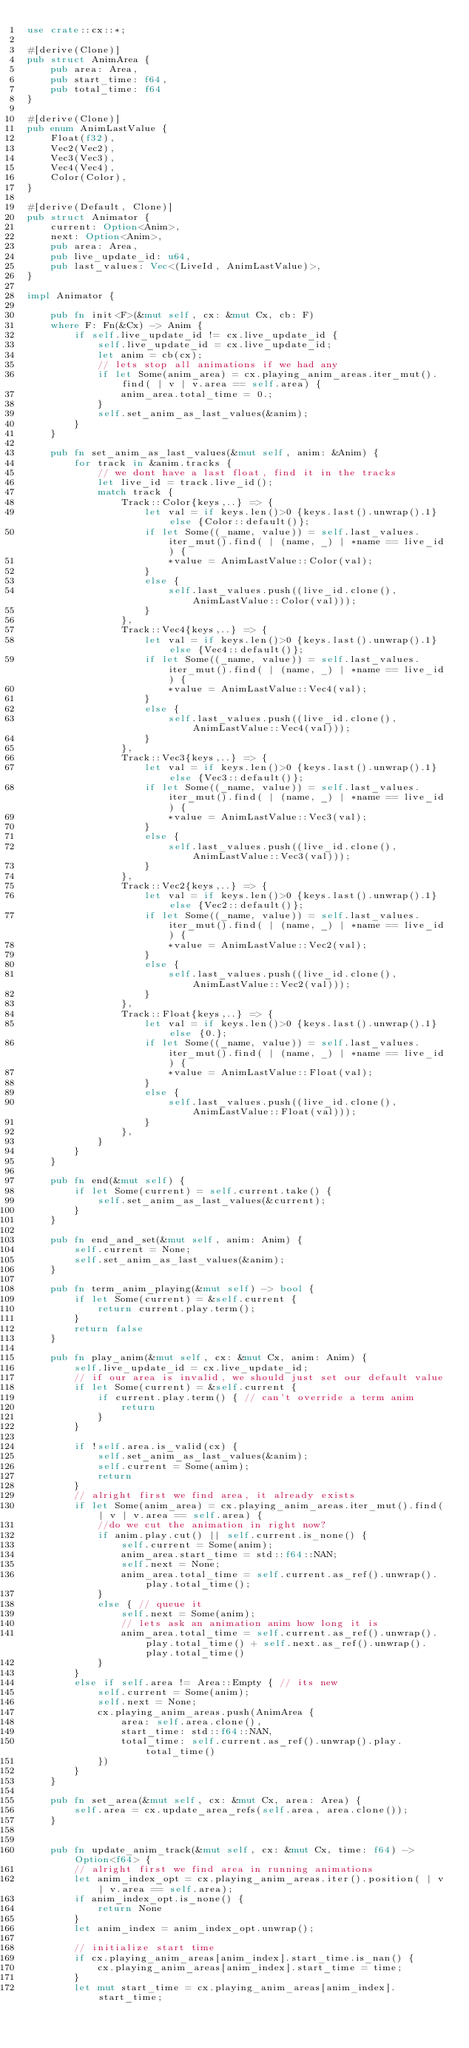<code> <loc_0><loc_0><loc_500><loc_500><_Rust_>use crate::cx::*;

#[derive(Clone)]
pub struct AnimArea {
    pub area: Area,
    pub start_time: f64,
    pub total_time: f64
}

#[derive(Clone)]
pub enum AnimLastValue {
    Float(f32), 
    Vec2(Vec2), 
    Vec3(Vec3),
    Vec4(Vec4),
    Color(Color),
}

#[derive(Default, Clone)]
pub struct Animator {
    current: Option<Anim>,
    next: Option<Anim>,
    pub area: Area,
    pub live_update_id: u64,
    pub last_values: Vec<(LiveId, AnimLastValue)>,
}

impl Animator {

    pub fn init<F>(&mut self, cx: &mut Cx, cb: F)
    where F: Fn(&Cx) -> Anim {
        if self.live_update_id != cx.live_update_id {
            self.live_update_id = cx.live_update_id;
            let anim = cb(cx);
            // lets stop all animations if we had any
            if let Some(anim_area) = cx.playing_anim_areas.iter_mut().find( | v | v.area == self.area) {
                anim_area.total_time = 0.;
            }
            self.set_anim_as_last_values(&anim);
        }
    }
    
    pub fn set_anim_as_last_values(&mut self, anim: &Anim) {
        for track in &anim.tracks {
            // we dont have a last float, find it in the tracks
            let live_id = track.live_id();
            match track {
                Track::Color{keys,..} => {
                    let val = if keys.len()>0 {keys.last().unwrap().1}else {Color::default()};
                    if let Some((_name, value)) = self.last_values.iter_mut().find( | (name, _) | *name == live_id) {
                        *value = AnimLastValue::Color(val);
                    }
                    else {
                        self.last_values.push((live_id.clone(), AnimLastValue::Color(val)));
                    }
                },
                Track::Vec4{keys,..} => {
                    let val = if keys.len()>0 {keys.last().unwrap().1}else {Vec4::default()};
                    if let Some((_name, value)) = self.last_values.iter_mut().find( | (name, _) | *name == live_id) {
                        *value = AnimLastValue::Vec4(val);
                    }
                    else {
                        self.last_values.push((live_id.clone(), AnimLastValue::Vec4(val)));
                    }
                },
                Track::Vec3{keys,..} => {
                    let val = if keys.len()>0 {keys.last().unwrap().1}else {Vec3::default()};
                    if let Some((_name, value)) = self.last_values.iter_mut().find( | (name, _) | *name == live_id) {
                        *value = AnimLastValue::Vec3(val);
                    }
                    else {
                        self.last_values.push((live_id.clone(), AnimLastValue::Vec3(val)));
                    }
                },
                Track::Vec2{keys,..} => {
                    let val = if keys.len()>0 {keys.last().unwrap().1}else {Vec2::default()};
                    if let Some((_name, value)) = self.last_values.iter_mut().find( | (name, _) | *name == live_id) {
                        *value = AnimLastValue::Vec2(val);
                    }
                    else {
                        self.last_values.push((live_id.clone(), AnimLastValue::Vec2(val)));
                    }
                },
                Track::Float{keys,..} => {
                    let val = if keys.len()>0 {keys.last().unwrap().1}else {0.};
                    if let Some((_name, value)) = self.last_values.iter_mut().find( | (name, _) | *name == live_id) {
                        *value = AnimLastValue::Float(val); 
                    }
                    else {
                        self.last_values.push((live_id.clone(), AnimLastValue::Float(val)));
                    }
                },
            }
        }
    }
    
    pub fn end(&mut self) {
        if let Some(current) = self.current.take() {
            self.set_anim_as_last_values(&current);
        }
    }
    
    pub fn end_and_set(&mut self, anim: Anim) {
        self.current = None;
        self.set_anim_as_last_values(&anim);
    }
    
    pub fn term_anim_playing(&mut self) -> bool {
        if let Some(current) = &self.current {
            return current.play.term();
        }
        return false
    }
    
    pub fn play_anim(&mut self, cx: &mut Cx, anim: Anim) {
        self.live_update_id = cx.live_update_id;
        // if our area is invalid, we should just set our default value
        if let Some(current) = &self.current {
            if current.play.term() { // can't override a term anim
                return
            }
        }

        if !self.area.is_valid(cx) {
            self.set_anim_as_last_values(&anim);
            self.current = Some(anim);
            return
        }
        // alright first we find area, it already exists
        if let Some(anim_area) = cx.playing_anim_areas.iter_mut().find( | v | v.area == self.area) {
            //do we cut the animation in right now?
            if anim.play.cut() || self.current.is_none() {
                self.current = Some(anim);
                anim_area.start_time = std::f64::NAN;
                self.next = None;
                anim_area.total_time = self.current.as_ref().unwrap().play.total_time();
            }
            else { // queue it
                self.next = Some(anim);
                // lets ask an animation anim how long it is
                anim_area.total_time = self.current.as_ref().unwrap().play.total_time() + self.next.as_ref().unwrap().play.total_time()
            }
        }
        else if self.area != Area::Empty { // its new
            self.current = Some(anim);
            self.next = None;
            cx.playing_anim_areas.push(AnimArea {
                area: self.area.clone(),
                start_time: std::f64::NAN,
                total_time: self.current.as_ref().unwrap().play.total_time()
            })
        }
    }
    
    pub fn set_area(&mut self, cx: &mut Cx, area: Area) {
        self.area = cx.update_area_refs(self.area, area.clone());
    }
    
    
    pub fn update_anim_track(&mut self, cx: &mut Cx, time: f64) -> Option<f64> {
        // alright first we find area in running animations
        let anim_index_opt = cx.playing_anim_areas.iter().position( | v | v.area == self.area);
        if anim_index_opt.is_none() {
            return None
        }
        let anim_index = anim_index_opt.unwrap();
        
        // initialize start time
        if cx.playing_anim_areas[anim_index].start_time.is_nan() {
            cx.playing_anim_areas[anim_index].start_time = time;
        }
        let mut start_time = cx.playing_anim_areas[anim_index].start_time;
        </code> 